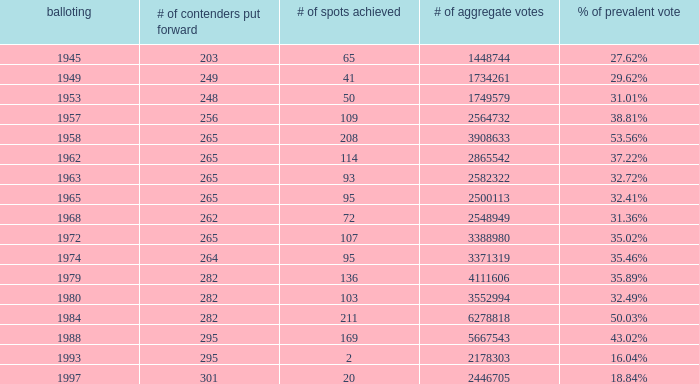What is the # of seats one for the election in 1974? 95.0. 